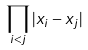<formula> <loc_0><loc_0><loc_500><loc_500>\prod _ { i < j } | x _ { i } - x _ { j } |</formula> 